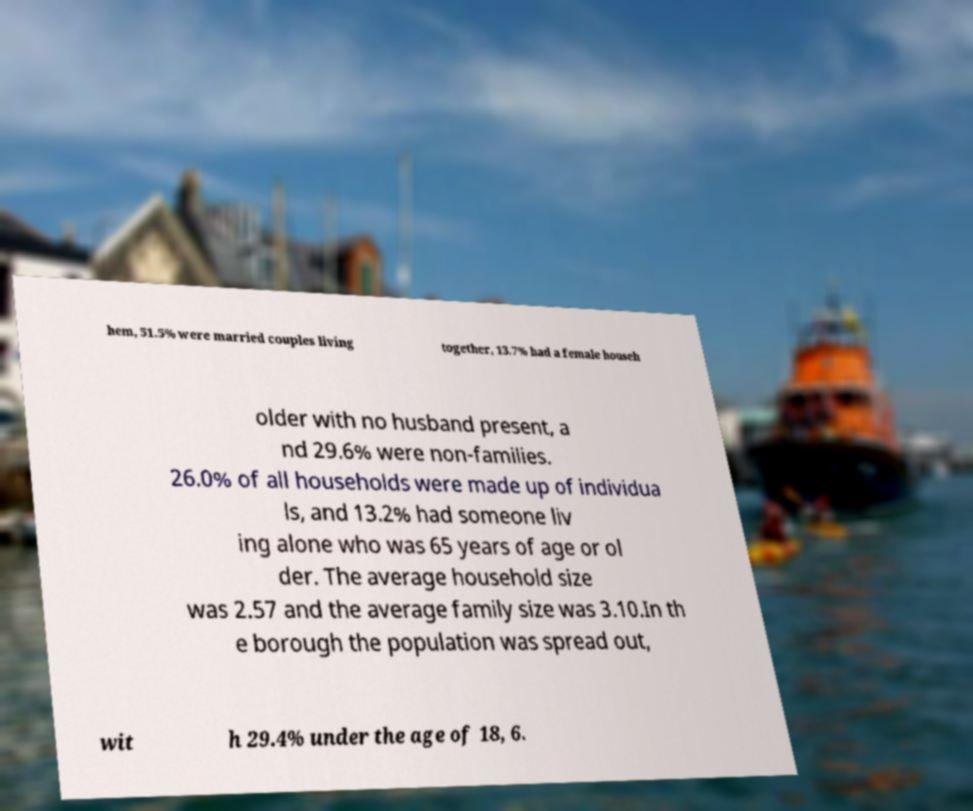Can you read and provide the text displayed in the image?This photo seems to have some interesting text. Can you extract and type it out for me? hem, 51.5% were married couples living together, 13.7% had a female househ older with no husband present, a nd 29.6% were non-families. 26.0% of all households were made up of individua ls, and 13.2% had someone liv ing alone who was 65 years of age or ol der. The average household size was 2.57 and the average family size was 3.10.In th e borough the population was spread out, wit h 29.4% under the age of 18, 6. 